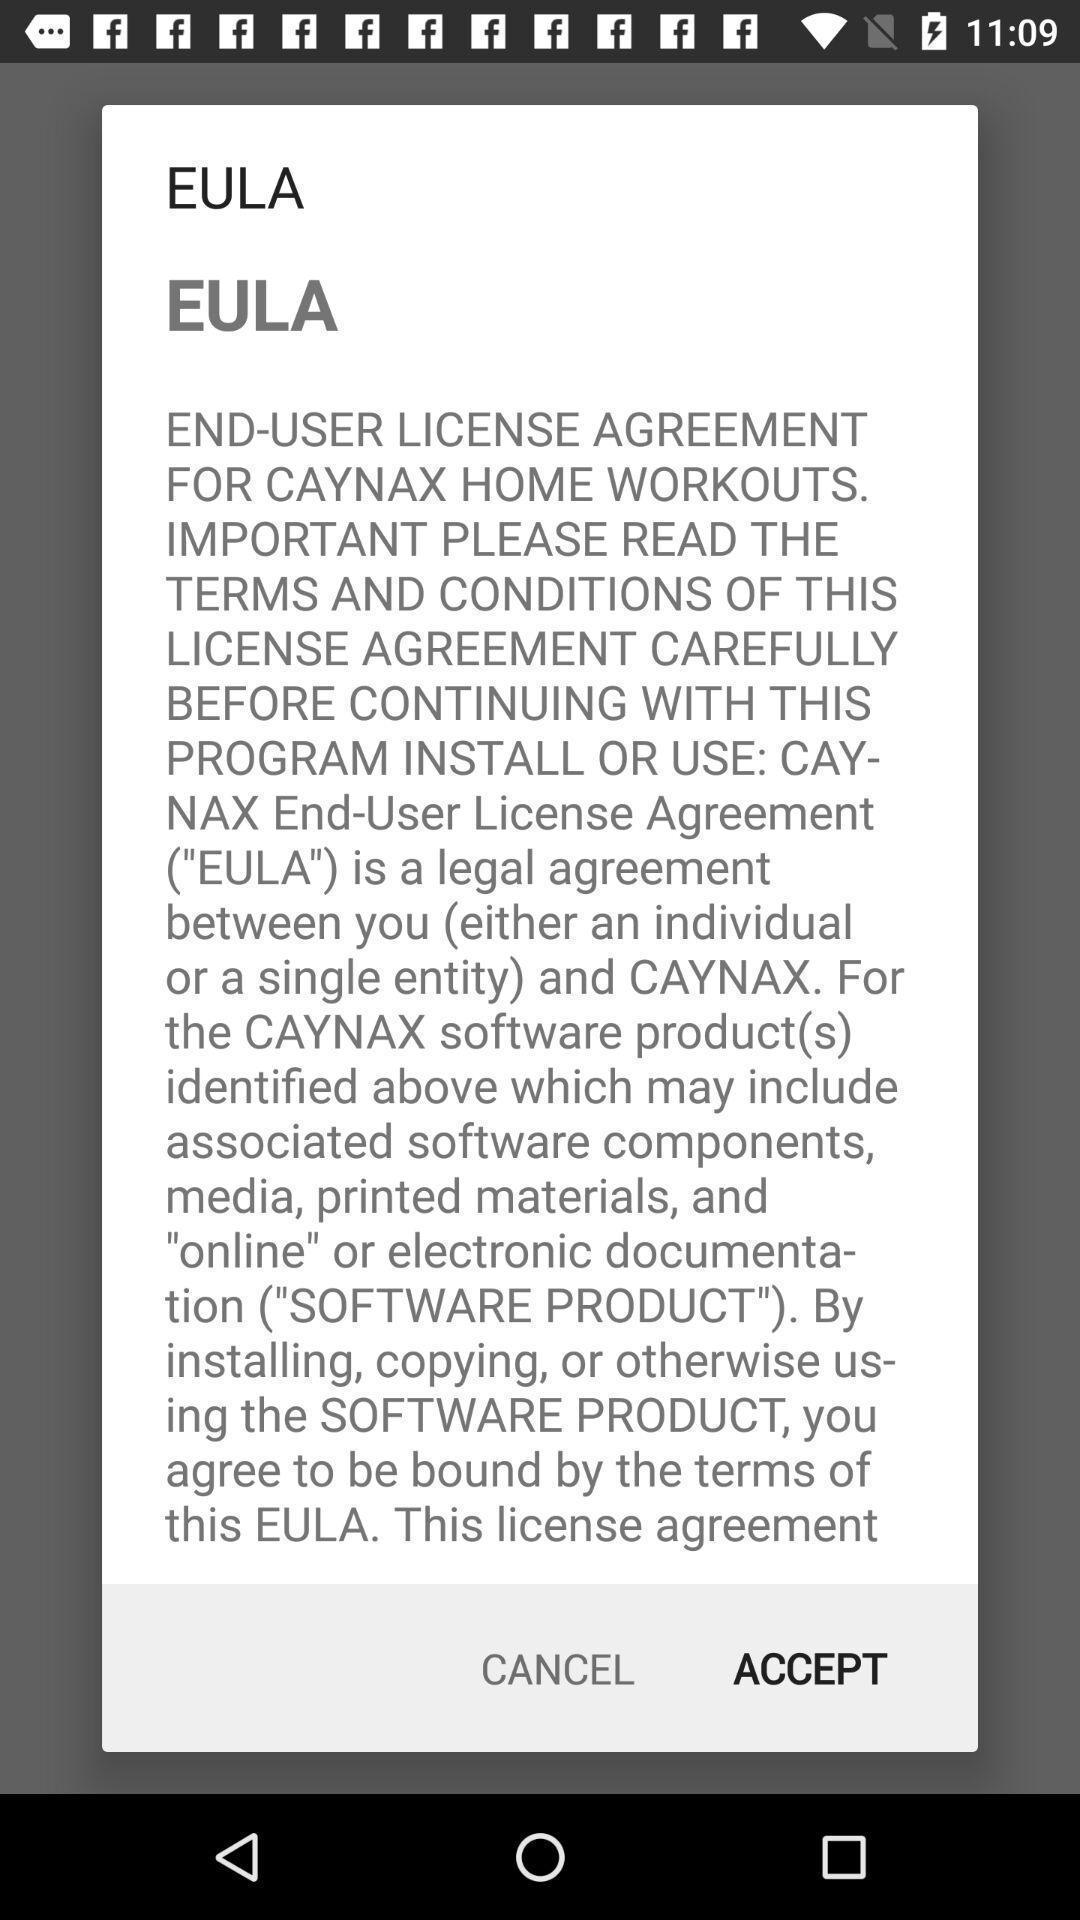What can you discern from this picture? Pop-up showing a license agreement of the app. 